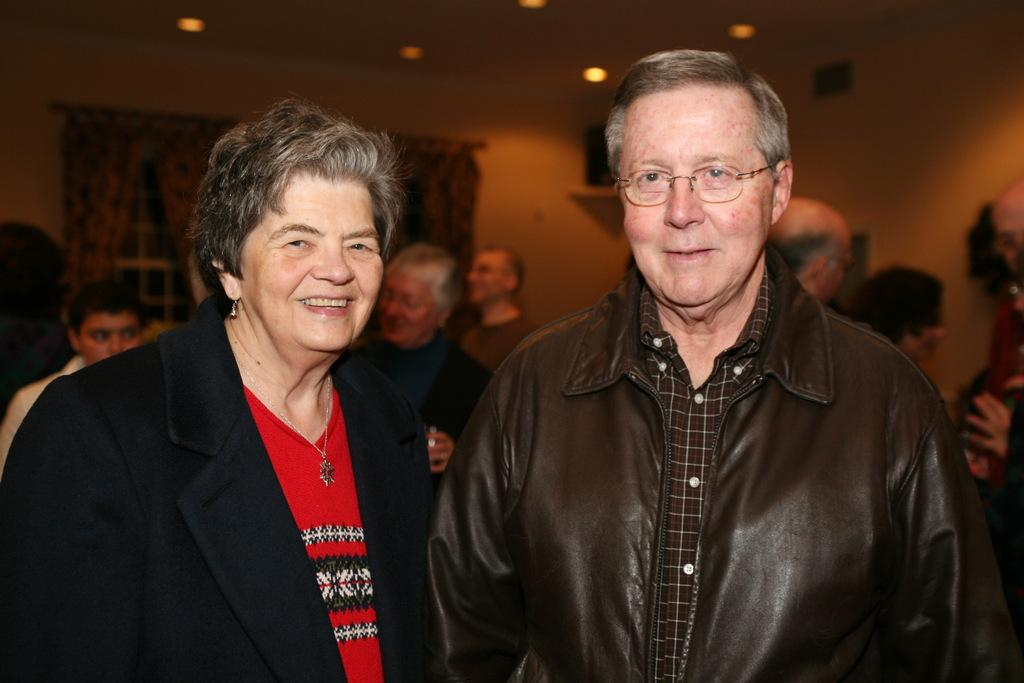Who is present in the picture? There is a couple in the picture. What are the couple doing in the picture? The couple is standing. Are there any other people in the picture besides the couple? Yes, there are other persons standing behind the couple. What can be seen above the people in the picture? There are lights attached to the roof above the people. What type of toy can be seen on the table in the picture? There is no table or toy present in the picture; it features a couple standing with other persons behind them. Where is the lunchroom located in the picture? There is no lunchroom present in the picture; it is an outdoor scene with people standing under lights attached to the roof. 